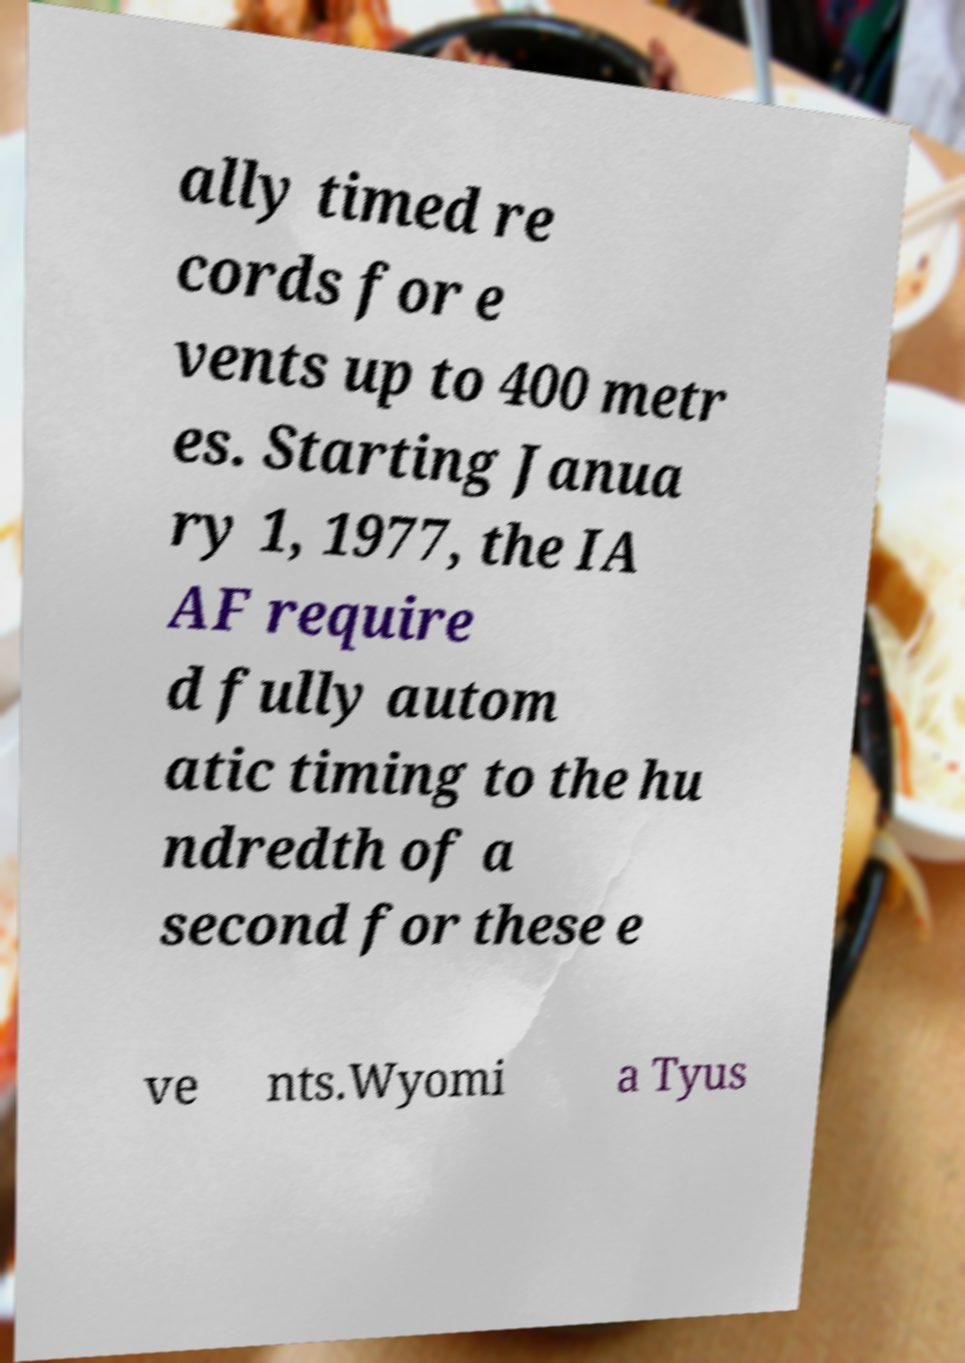Please identify and transcribe the text found in this image. ally timed re cords for e vents up to 400 metr es. Starting Janua ry 1, 1977, the IA AF require d fully autom atic timing to the hu ndredth of a second for these e ve nts.Wyomi a Tyus 